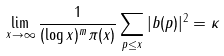Convert formula to latex. <formula><loc_0><loc_0><loc_500><loc_500>\lim _ { x \to \infty } \frac { 1 } { ( \log x ) ^ { m } \pi ( x ) } \sum _ { p \leq x } | b ( p ) | ^ { 2 } = \kappa</formula> 